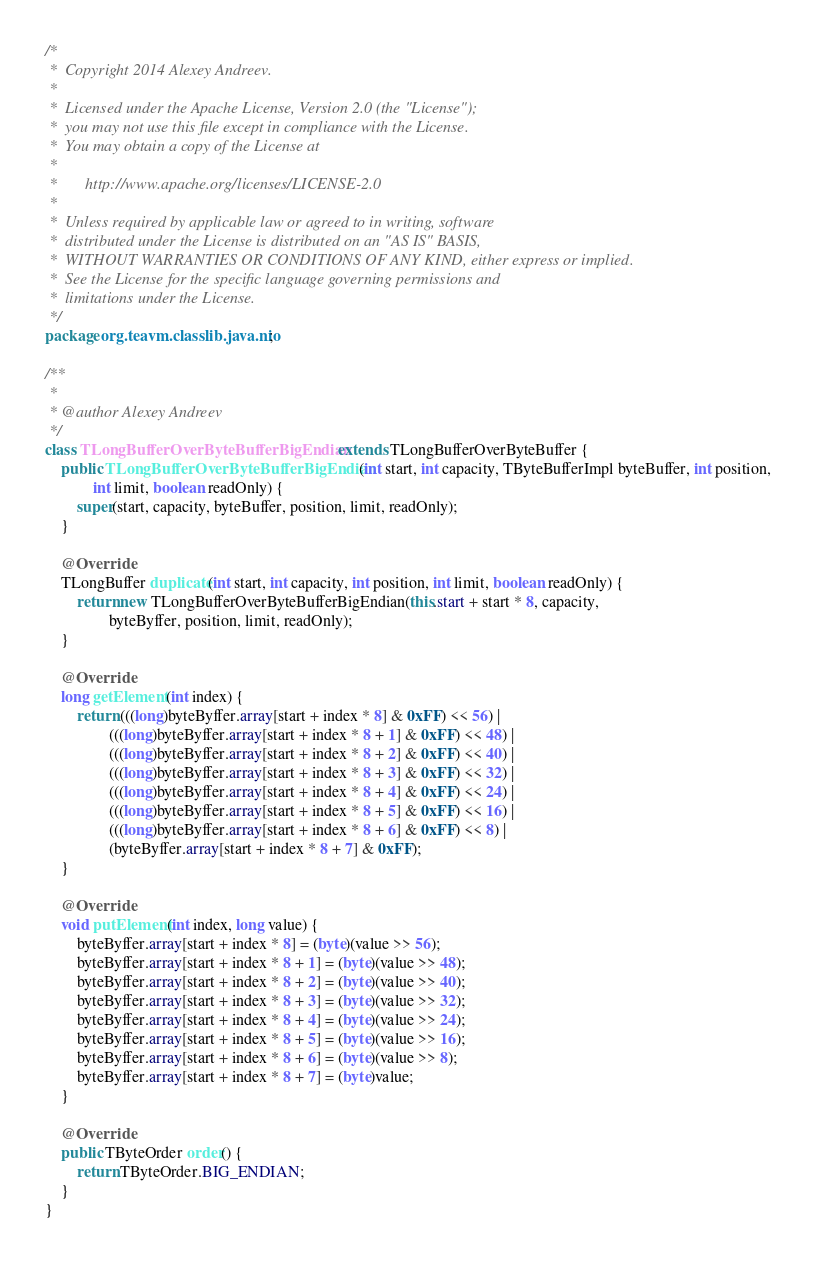Convert code to text. <code><loc_0><loc_0><loc_500><loc_500><_Java_>/*
 *  Copyright 2014 Alexey Andreev.
 *
 *  Licensed under the Apache License, Version 2.0 (the "License");
 *  you may not use this file except in compliance with the License.
 *  You may obtain a copy of the License at
 *
 *       http://www.apache.org/licenses/LICENSE-2.0
 *
 *  Unless required by applicable law or agreed to in writing, software
 *  distributed under the License is distributed on an "AS IS" BASIS,
 *  WITHOUT WARRANTIES OR CONDITIONS OF ANY KIND, either express or implied.
 *  See the License for the specific language governing permissions and
 *  limitations under the License.
 */
package org.teavm.classlib.java.nio;

/**
 *
 * @author Alexey Andreev
 */
class TLongBufferOverByteBufferBigEndian extends TLongBufferOverByteBuffer {
    public TLongBufferOverByteBufferBigEndian(int start, int capacity, TByteBufferImpl byteBuffer, int position,
            int limit, boolean readOnly) {
        super(start, capacity, byteBuffer, position, limit, readOnly);
    }

    @Override
    TLongBuffer duplicate(int start, int capacity, int position, int limit, boolean readOnly) {
        return new TLongBufferOverByteBufferBigEndian(this.start + start * 8, capacity,
                byteByffer, position, limit, readOnly);
    }

    @Override
    long getElement(int index) {
        return (((long)byteByffer.array[start + index * 8] & 0xFF) << 56) |
                (((long)byteByffer.array[start + index * 8 + 1] & 0xFF) << 48) |
                (((long)byteByffer.array[start + index * 8 + 2] & 0xFF) << 40) |
                (((long)byteByffer.array[start + index * 8 + 3] & 0xFF) << 32) |
                (((long)byteByffer.array[start + index * 8 + 4] & 0xFF) << 24) |
                (((long)byteByffer.array[start + index * 8 + 5] & 0xFF) << 16) |
                (((long)byteByffer.array[start + index * 8 + 6] & 0xFF) << 8) |
                (byteByffer.array[start + index * 8 + 7] & 0xFF);
    }

    @Override
    void putElement(int index, long value) {
        byteByffer.array[start + index * 8] = (byte)(value >> 56);
        byteByffer.array[start + index * 8 + 1] = (byte)(value >> 48);
        byteByffer.array[start + index * 8 + 2] = (byte)(value >> 40);
        byteByffer.array[start + index * 8 + 3] = (byte)(value >> 32);
        byteByffer.array[start + index * 8 + 4] = (byte)(value >> 24);
        byteByffer.array[start + index * 8 + 5] = (byte)(value >> 16);
        byteByffer.array[start + index * 8 + 6] = (byte)(value >> 8);
        byteByffer.array[start + index * 8 + 7] = (byte)value;
    }

    @Override
    public TByteOrder order() {
        return TByteOrder.BIG_ENDIAN;
    }
}
</code> 